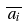<formula> <loc_0><loc_0><loc_500><loc_500>\overline { a _ { i } }</formula> 